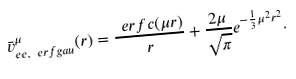<formula> <loc_0><loc_0><loc_500><loc_500>\bar { v } _ { e e , \ e r f g a u } ^ { \mu } ( r ) = \frac { \ e r f c ( \mu r ) } { r } + \frac { 2 \mu } { \sqrt { \pi } } e ^ { - \frac { 1 } { 3 } \mu ^ { 2 } r ^ { 2 } } .</formula> 